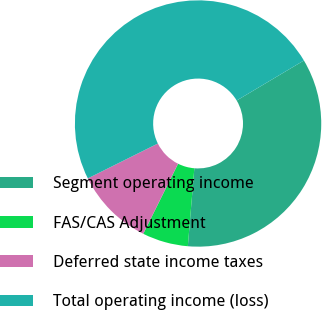Convert chart to OTSL. <chart><loc_0><loc_0><loc_500><loc_500><pie_chart><fcel>Segment operating income<fcel>FAS/CAS Adjustment<fcel>Deferred state income taxes<fcel>Total operating income (loss)<nl><fcel>34.87%<fcel>6.02%<fcel>10.3%<fcel>48.81%<nl></chart> 